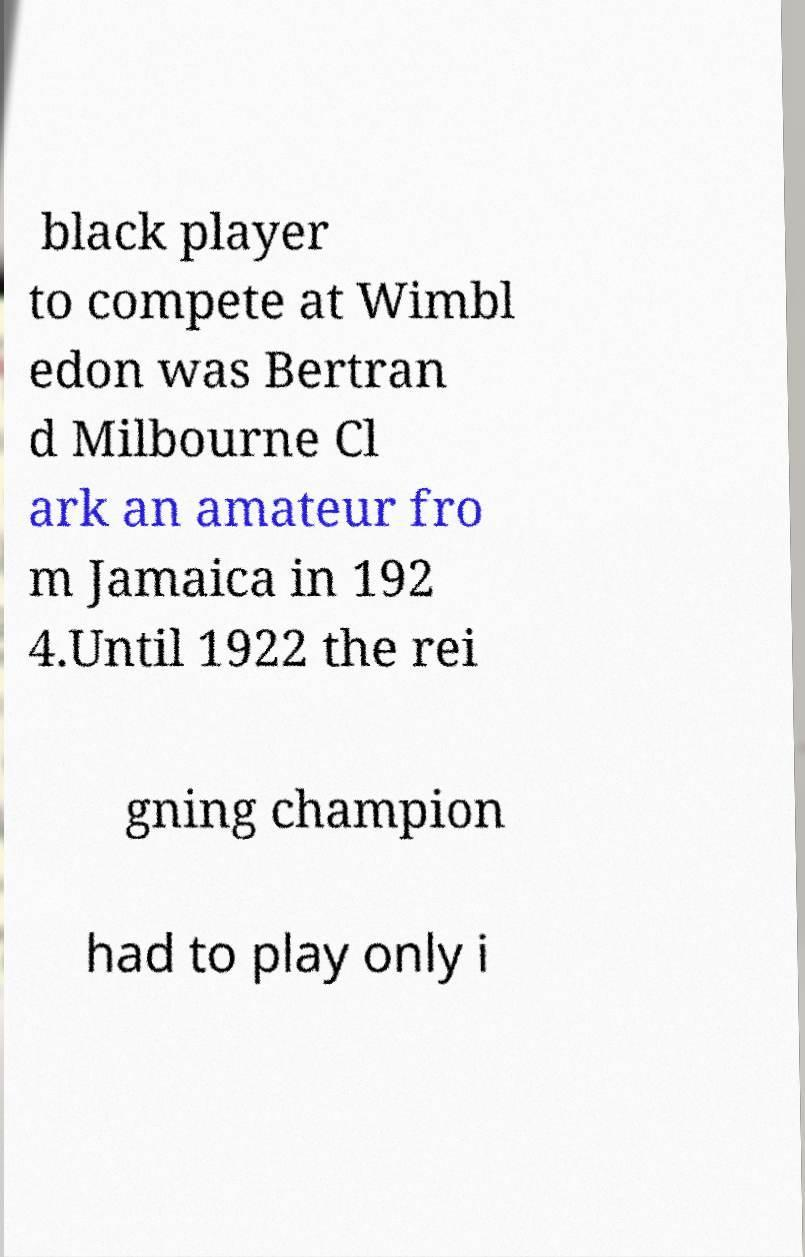Can you accurately transcribe the text from the provided image for me? black player to compete at Wimbl edon was Bertran d Milbourne Cl ark an amateur fro m Jamaica in 192 4.Until 1922 the rei gning champion had to play only i 